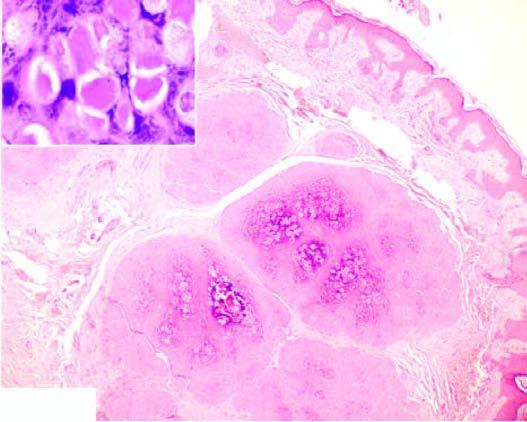what do the epidermal layers show?
Answer the question using a single word or phrase. Numerous molluscum bodies which are intracytoplasmic inclusions 